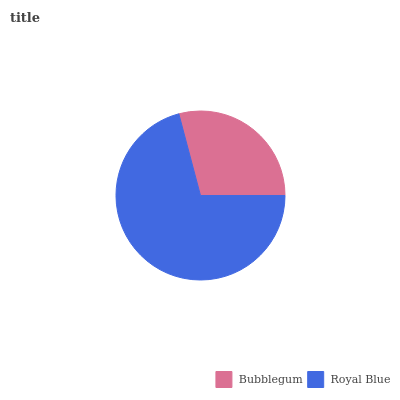Is Bubblegum the minimum?
Answer yes or no. Yes. Is Royal Blue the maximum?
Answer yes or no. Yes. Is Royal Blue the minimum?
Answer yes or no. No. Is Royal Blue greater than Bubblegum?
Answer yes or no. Yes. Is Bubblegum less than Royal Blue?
Answer yes or no. Yes. Is Bubblegum greater than Royal Blue?
Answer yes or no. No. Is Royal Blue less than Bubblegum?
Answer yes or no. No. Is Royal Blue the high median?
Answer yes or no. Yes. Is Bubblegum the low median?
Answer yes or no. Yes. Is Bubblegum the high median?
Answer yes or no. No. Is Royal Blue the low median?
Answer yes or no. No. 